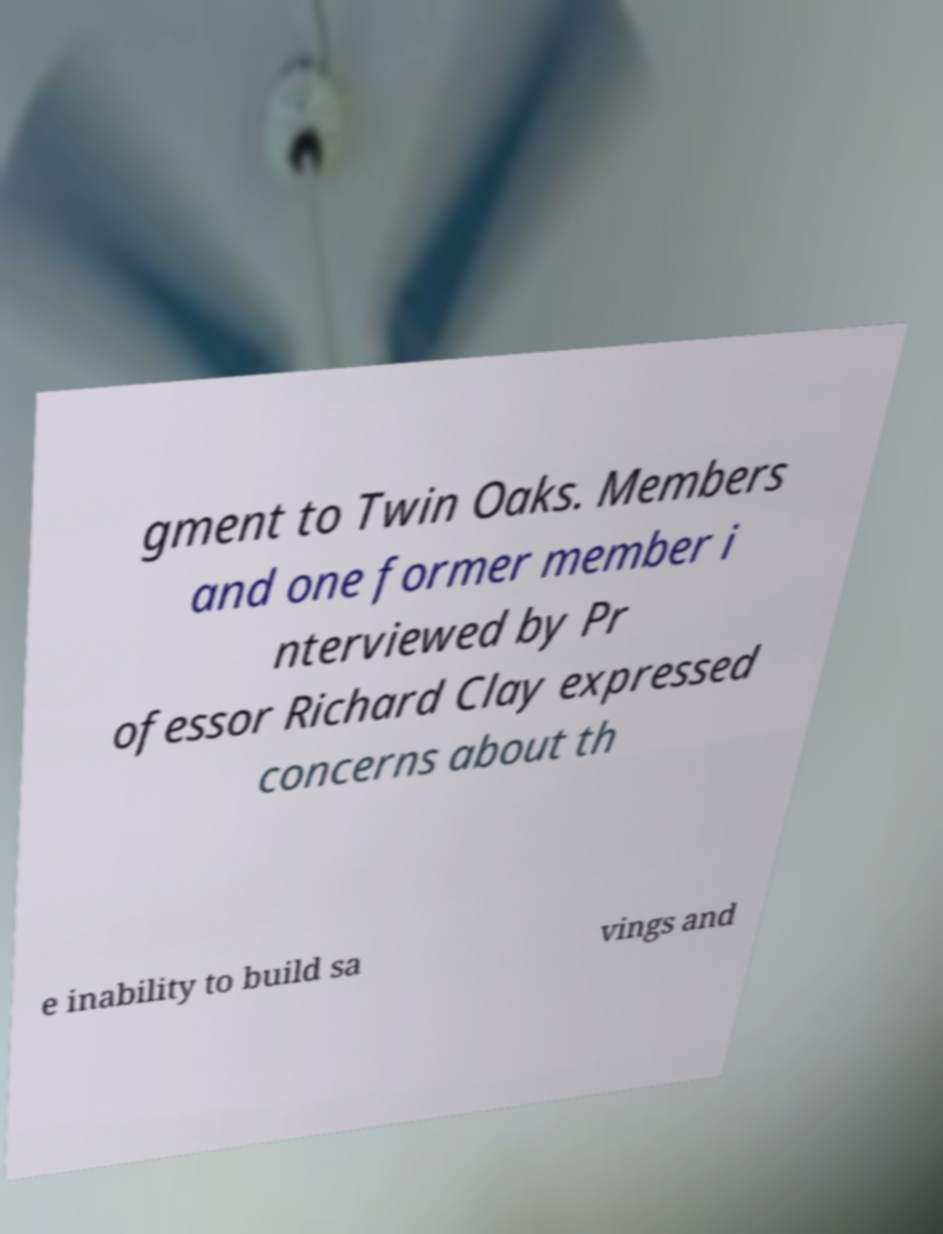There's text embedded in this image that I need extracted. Can you transcribe it verbatim? gment to Twin Oaks. Members and one former member i nterviewed by Pr ofessor Richard Clay expressed concerns about th e inability to build sa vings and 